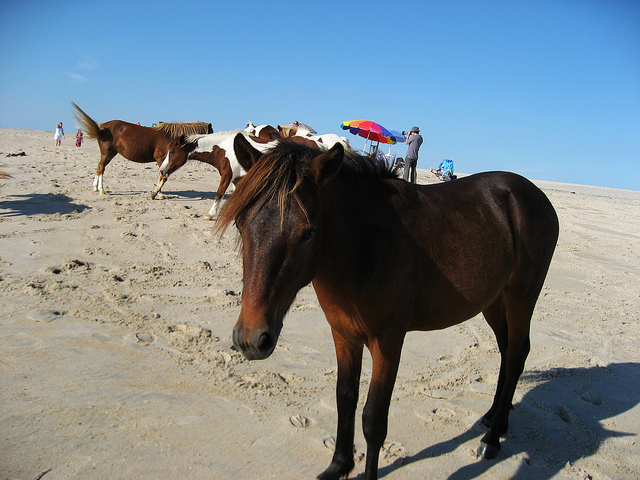<image>Why is the horse on the beach? I am not sure why the horse is on the beach. It could be there for a photo shoot, transportation, walking, or giving rides. Why is the horse on the beach? I don't know why the horse is on the beach. It can be for various reasons such as photography, giving rides, or for a photo shoot. 